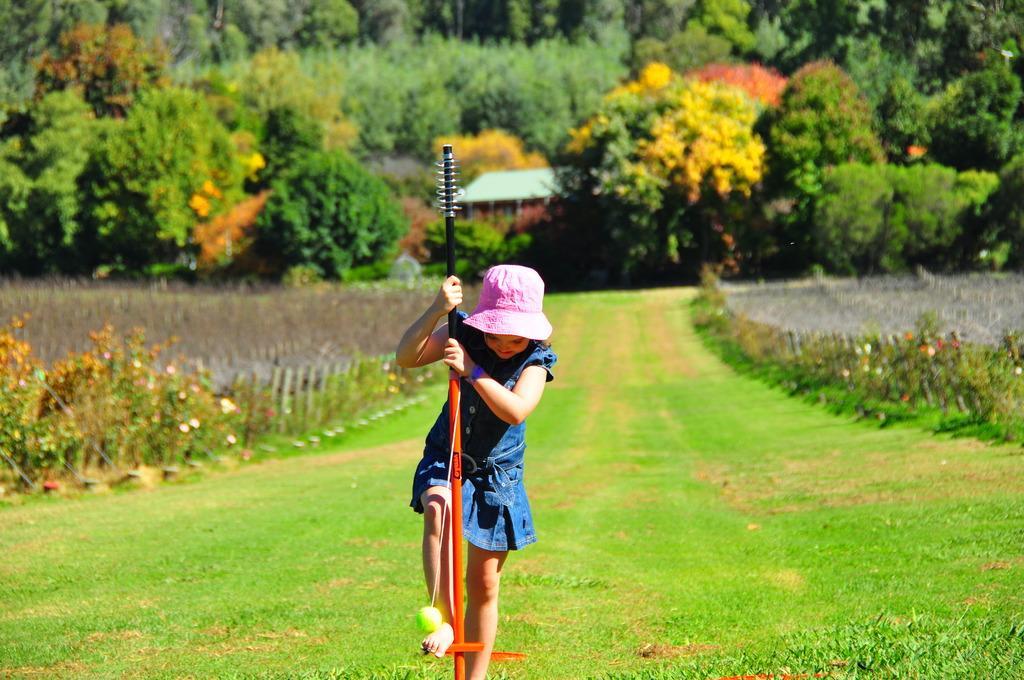Please provide a concise description of this image. In this image I can see there is a girl stepping on this orange color pole, she wears a blue color frock and a pink color cap. At the background, in the middle there is the house, around this house there are green color trees. 